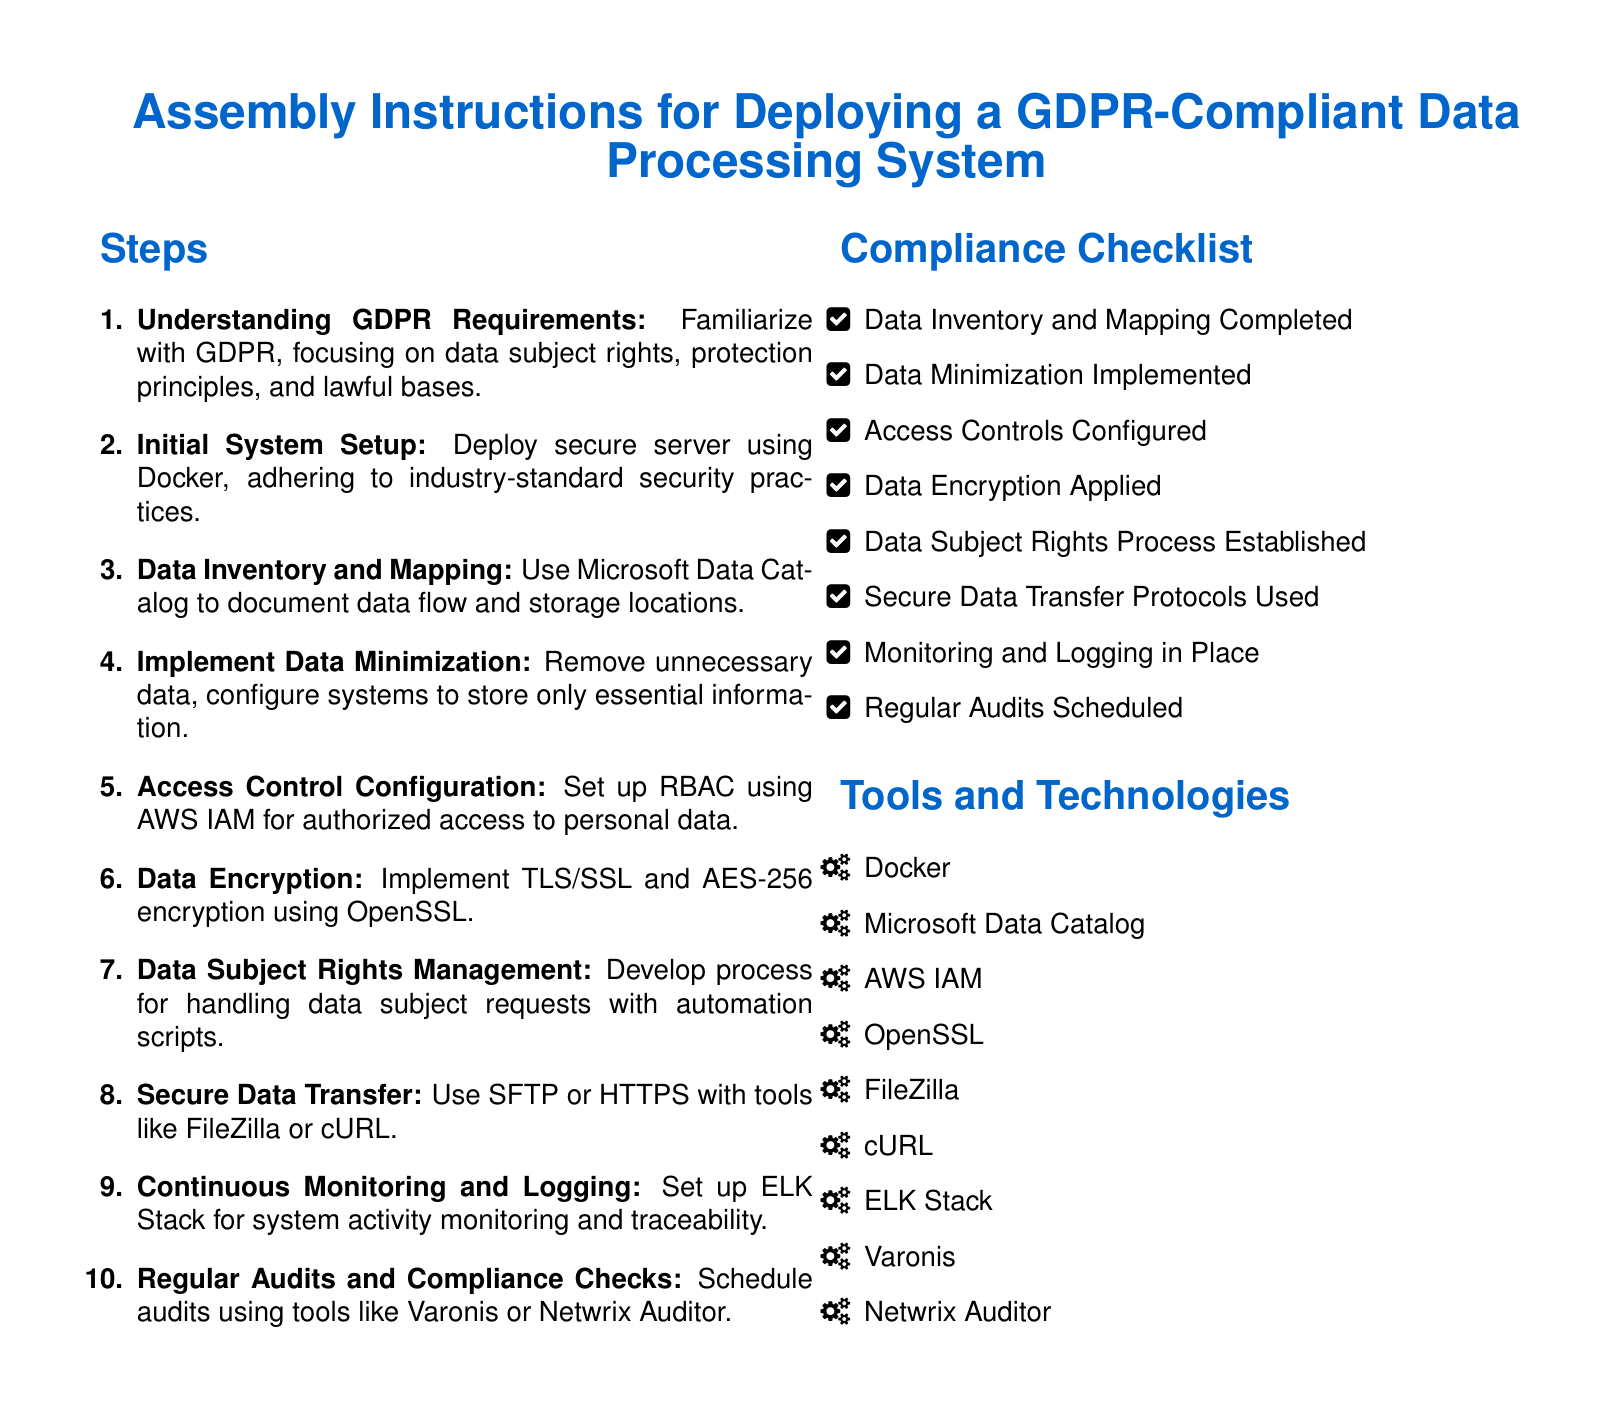What is the title of the document? The title in the document is provided prominently in the center, outlining the main focus.
Answer: Assembly Instructions for Deploying a GDPR-Compliant Data Processing System How many steps are outlined in the assembly instructions? The document clearly lists the steps in a numbered format.
Answer: 10 What is the first step in the assembly instructions? The first step is indicated as number one in the list of steps.
Answer: Understanding GDPR Requirements Which tool is suggested for data inventory and mapping? The document specifies a particular tool for mapping data in the relevant section.
Answer: Microsoft Data Catalog What is the encryption standard mentioned for data security? The assembly instructions include a specific encryption standard in the steps for data encryption.
Answer: AES-256 What does RBAC stand for, as referenced in access control configuration? The document mentions the acronym in the context of access control.
Answer: Role-Based Access Control How many items are in the compliance checklist? The checklist consists of several items, and the number is indicated in the bulleted list.
Answer: 8 What is the purpose of the ELK Stack according to the document? The document clarifies the role of the ELK Stack in the context of monitoring the system.
Answer: Continuous Monitoring and Logging Is there a requirement for regular audits according to the checklist? The compliance checklist reflects certain requirements that must be checked regularly.
Answer: Yes 